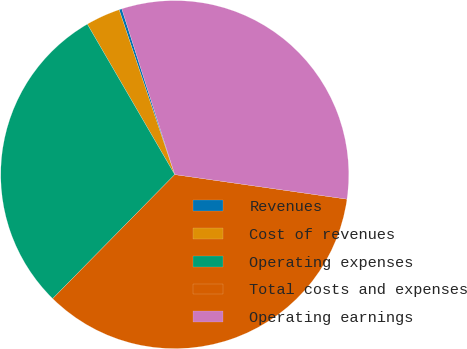Convert chart to OTSL. <chart><loc_0><loc_0><loc_500><loc_500><pie_chart><fcel>Revenues<fcel>Cost of revenues<fcel>Operating expenses<fcel>Total costs and expenses<fcel>Operating earnings<nl><fcel>0.26%<fcel>3.2%<fcel>29.25%<fcel>35.12%<fcel>32.18%<nl></chart> 